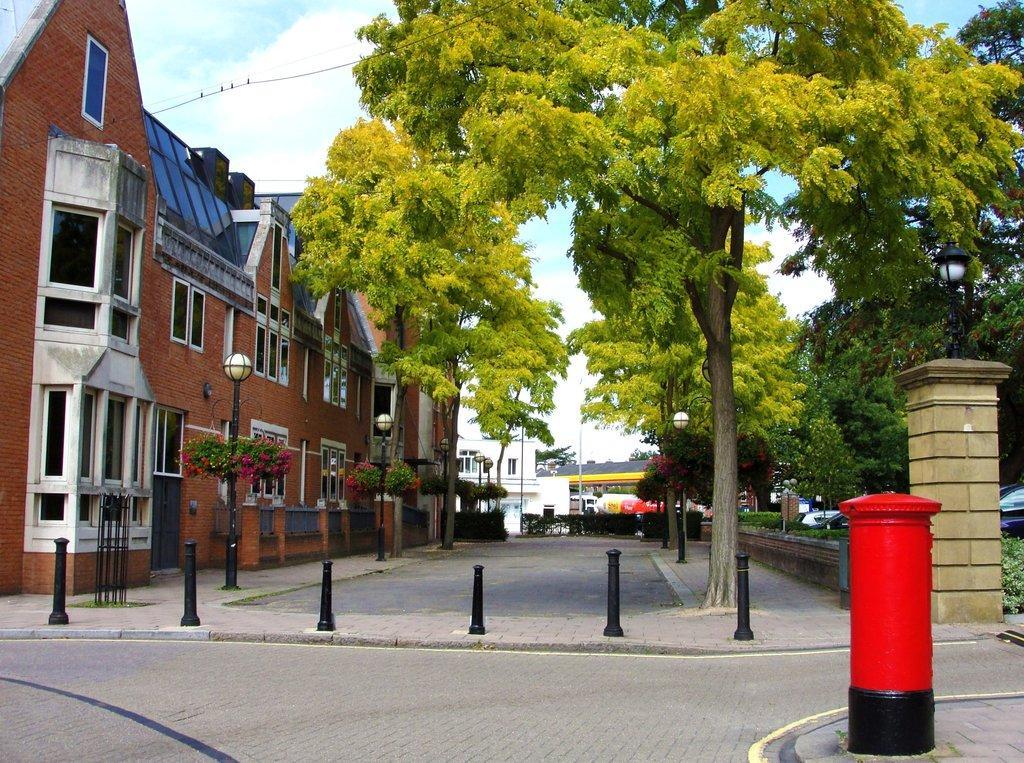Please provide a concise description of this image. This image consists of a building in brown color along with windows and doors. At the bottom, there is a road. In the front, there are trees. To the right, there is a post box. At the top, there are clouds in the sky. 